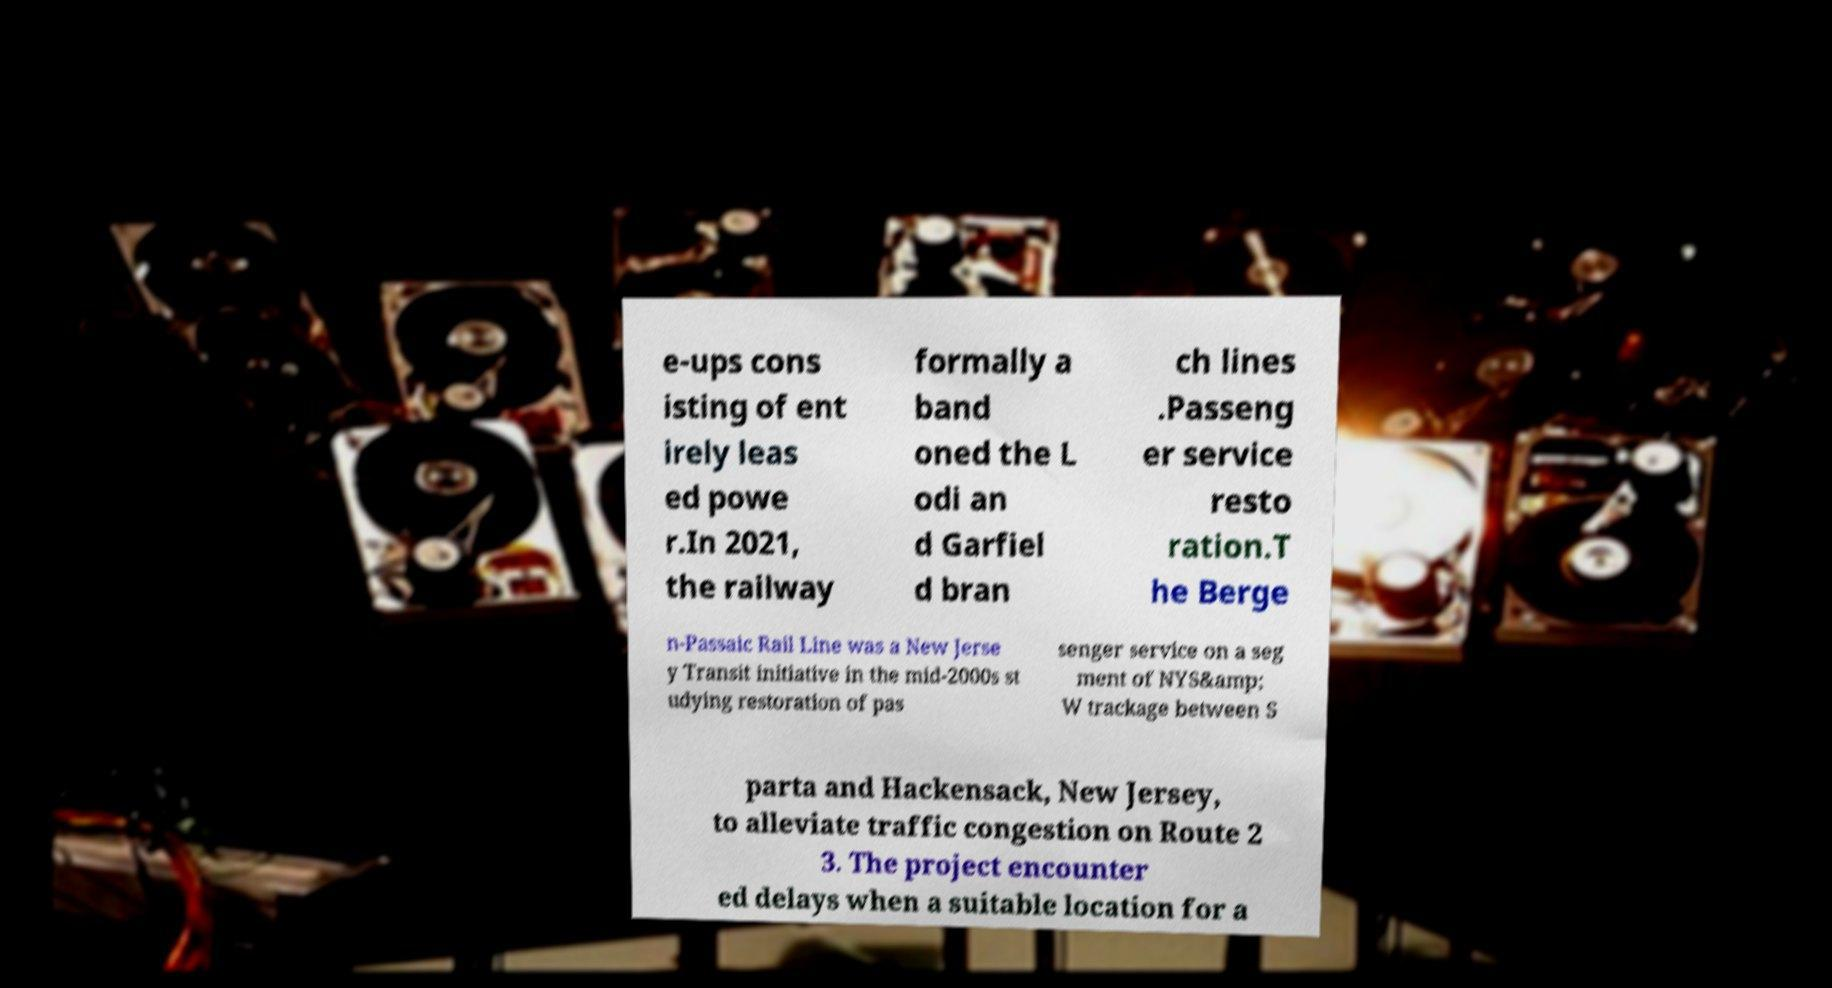Could you assist in decoding the text presented in this image and type it out clearly? e-ups cons isting of ent irely leas ed powe r.In 2021, the railway formally a band oned the L odi an d Garfiel d bran ch lines .Passeng er service resto ration.T he Berge n-Passaic Rail Line was a New Jerse y Transit initiative in the mid-2000s st udying restoration of pas senger service on a seg ment of NYS&amp; W trackage between S parta and Hackensack, New Jersey, to alleviate traffic congestion on Route 2 3. The project encounter ed delays when a suitable location for a 